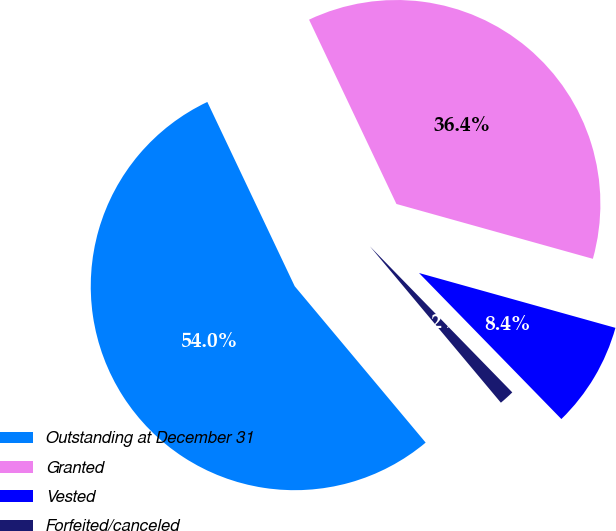Convert chart to OTSL. <chart><loc_0><loc_0><loc_500><loc_500><pie_chart><fcel>Outstanding at December 31<fcel>Granted<fcel>Vested<fcel>Forfeited/canceled<nl><fcel>54.05%<fcel>36.38%<fcel>8.37%<fcel>1.2%<nl></chart> 